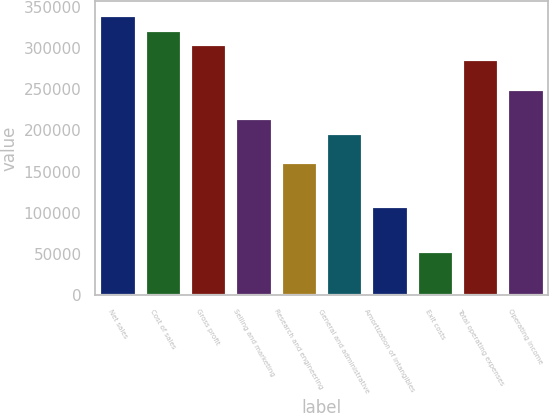<chart> <loc_0><loc_0><loc_500><loc_500><bar_chart><fcel>Net sales<fcel>Cost of sales<fcel>Gross profit<fcel>Selling and marketing<fcel>Research and engineering<fcel>General and administrative<fcel>Amortization of intangibles<fcel>Exit costs<fcel>Total operating expenses<fcel>Operating income<nl><fcel>340658<fcel>322729<fcel>304800<fcel>215153<fcel>161365<fcel>197223<fcel>107577<fcel>53788.5<fcel>286870<fcel>251011<nl></chart> 